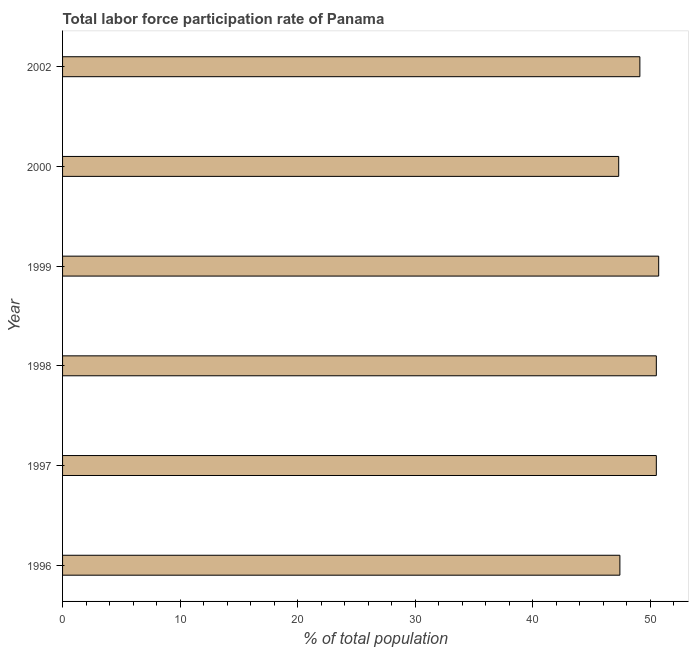Does the graph contain grids?
Your answer should be very brief. No. What is the title of the graph?
Provide a succinct answer. Total labor force participation rate of Panama. What is the label or title of the X-axis?
Ensure brevity in your answer.  % of total population. What is the total labor force participation rate in 2000?
Keep it short and to the point. 47.3. Across all years, what is the maximum total labor force participation rate?
Your answer should be very brief. 50.7. Across all years, what is the minimum total labor force participation rate?
Offer a terse response. 47.3. In which year was the total labor force participation rate maximum?
Make the answer very short. 1999. In which year was the total labor force participation rate minimum?
Offer a very short reply. 2000. What is the sum of the total labor force participation rate?
Ensure brevity in your answer.  295.5. What is the average total labor force participation rate per year?
Keep it short and to the point. 49.25. What is the median total labor force participation rate?
Offer a terse response. 49.8. In how many years, is the total labor force participation rate greater than 48 %?
Your answer should be compact. 4. Do a majority of the years between 2000 and 1996 (inclusive) have total labor force participation rate greater than 12 %?
Provide a succinct answer. Yes. Is the difference between the total labor force participation rate in 1998 and 2000 greater than the difference between any two years?
Make the answer very short. No. How many bars are there?
Offer a terse response. 6. What is the difference between two consecutive major ticks on the X-axis?
Ensure brevity in your answer.  10. Are the values on the major ticks of X-axis written in scientific E-notation?
Give a very brief answer. No. What is the % of total population in 1996?
Your response must be concise. 47.4. What is the % of total population in 1997?
Offer a very short reply. 50.5. What is the % of total population in 1998?
Your answer should be compact. 50.5. What is the % of total population of 1999?
Offer a very short reply. 50.7. What is the % of total population of 2000?
Your response must be concise. 47.3. What is the % of total population in 2002?
Provide a succinct answer. 49.1. What is the difference between the % of total population in 1996 and 1998?
Make the answer very short. -3.1. What is the difference between the % of total population in 1996 and 1999?
Keep it short and to the point. -3.3. What is the difference between the % of total population in 1997 and 1999?
Your answer should be very brief. -0.2. What is the difference between the % of total population in 1997 and 2002?
Your answer should be very brief. 1.4. What is the difference between the % of total population in 1999 and 2000?
Offer a very short reply. 3.4. What is the difference between the % of total population in 1999 and 2002?
Your answer should be compact. 1.6. What is the ratio of the % of total population in 1996 to that in 1997?
Your answer should be compact. 0.94. What is the ratio of the % of total population in 1996 to that in 1998?
Provide a succinct answer. 0.94. What is the ratio of the % of total population in 1996 to that in 1999?
Your answer should be very brief. 0.94. What is the ratio of the % of total population in 1997 to that in 1999?
Offer a very short reply. 1. What is the ratio of the % of total population in 1997 to that in 2000?
Your answer should be compact. 1.07. What is the ratio of the % of total population in 1998 to that in 1999?
Give a very brief answer. 1. What is the ratio of the % of total population in 1998 to that in 2000?
Provide a short and direct response. 1.07. What is the ratio of the % of total population in 1998 to that in 2002?
Offer a very short reply. 1.03. What is the ratio of the % of total population in 1999 to that in 2000?
Provide a short and direct response. 1.07. What is the ratio of the % of total population in 1999 to that in 2002?
Ensure brevity in your answer.  1.03. What is the ratio of the % of total population in 2000 to that in 2002?
Provide a succinct answer. 0.96. 